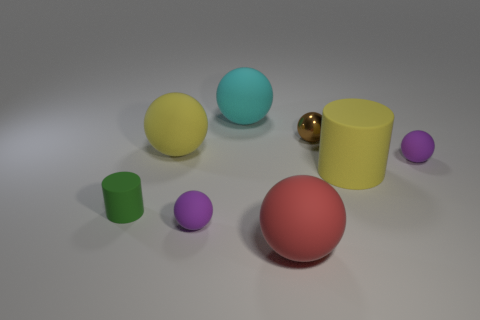Subtract all purple spheres. How many spheres are left? 4 Subtract all big cyan spheres. How many spheres are left? 5 Subtract all yellow balls. Subtract all green cubes. How many balls are left? 5 Add 1 tiny metallic objects. How many objects exist? 9 Subtract all spheres. How many objects are left? 2 Add 7 brown balls. How many brown balls are left? 8 Add 1 small metallic things. How many small metallic things exist? 2 Subtract 0 brown blocks. How many objects are left? 8 Subtract all big red objects. Subtract all small cylinders. How many objects are left? 6 